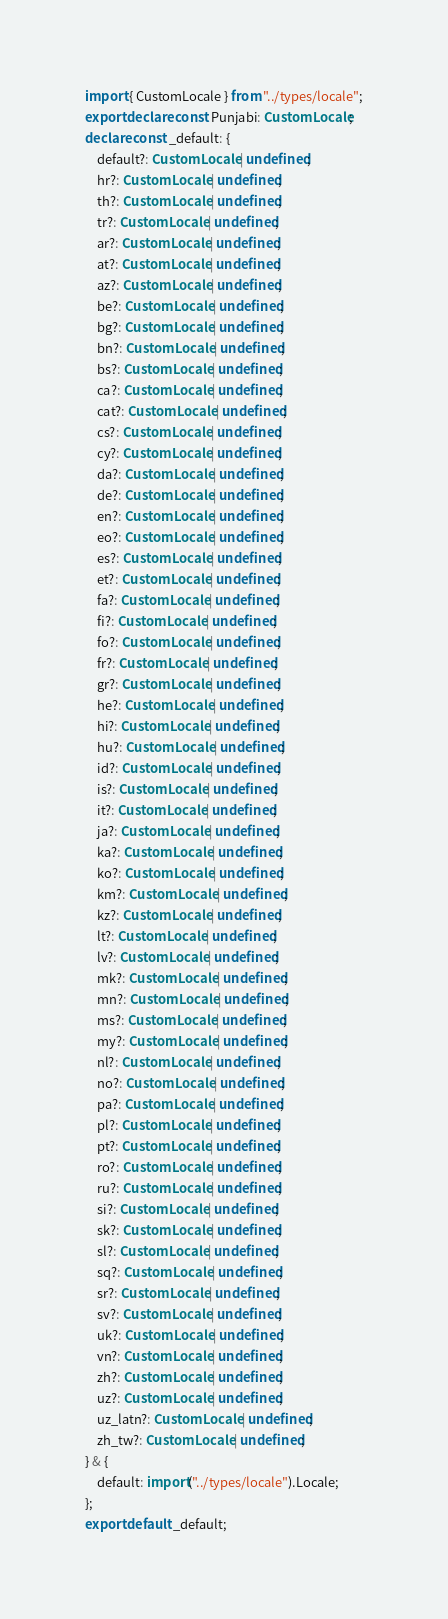<code> <loc_0><loc_0><loc_500><loc_500><_TypeScript_>import { CustomLocale } from "../types/locale";
export declare const Punjabi: CustomLocale;
declare const _default: {
    default?: CustomLocale | undefined;
    hr?: CustomLocale | undefined;
    th?: CustomLocale | undefined;
    tr?: CustomLocale | undefined;
    ar?: CustomLocale | undefined;
    at?: CustomLocale | undefined;
    az?: CustomLocale | undefined;
    be?: CustomLocale | undefined;
    bg?: CustomLocale | undefined;
    bn?: CustomLocale | undefined;
    bs?: CustomLocale | undefined;
    ca?: CustomLocale | undefined;
    cat?: CustomLocale | undefined;
    cs?: CustomLocale | undefined;
    cy?: CustomLocale | undefined;
    da?: CustomLocale | undefined;
    de?: CustomLocale | undefined;
    en?: CustomLocale | undefined;
    eo?: CustomLocale | undefined;
    es?: CustomLocale | undefined;
    et?: CustomLocale | undefined;
    fa?: CustomLocale | undefined;
    fi?: CustomLocale | undefined;
    fo?: CustomLocale | undefined;
    fr?: CustomLocale | undefined;
    gr?: CustomLocale | undefined;
    he?: CustomLocale | undefined;
    hi?: CustomLocale | undefined;
    hu?: CustomLocale | undefined;
    id?: CustomLocale | undefined;
    is?: CustomLocale | undefined;
    it?: CustomLocale | undefined;
    ja?: CustomLocale | undefined;
    ka?: CustomLocale | undefined;
    ko?: CustomLocale | undefined;
    km?: CustomLocale | undefined;
    kz?: CustomLocale | undefined;
    lt?: CustomLocale | undefined;
    lv?: CustomLocale | undefined;
    mk?: CustomLocale | undefined;
    mn?: CustomLocale | undefined;
    ms?: CustomLocale | undefined;
    my?: CustomLocale | undefined;
    nl?: CustomLocale | undefined;
    no?: CustomLocale | undefined;
    pa?: CustomLocale | undefined;
    pl?: CustomLocale | undefined;
    pt?: CustomLocale | undefined;
    ro?: CustomLocale | undefined;
    ru?: CustomLocale | undefined;
    si?: CustomLocale | undefined;
    sk?: CustomLocale | undefined;
    sl?: CustomLocale | undefined;
    sq?: CustomLocale | undefined;
    sr?: CustomLocale | undefined;
    sv?: CustomLocale | undefined;
    uk?: CustomLocale | undefined;
    vn?: CustomLocale | undefined;
    zh?: CustomLocale | undefined;
    uz?: CustomLocale | undefined;
    uz_latn?: CustomLocale | undefined;
    zh_tw?: CustomLocale | undefined;
} & {
    default: import("../types/locale").Locale;
};
export default _default;
</code> 